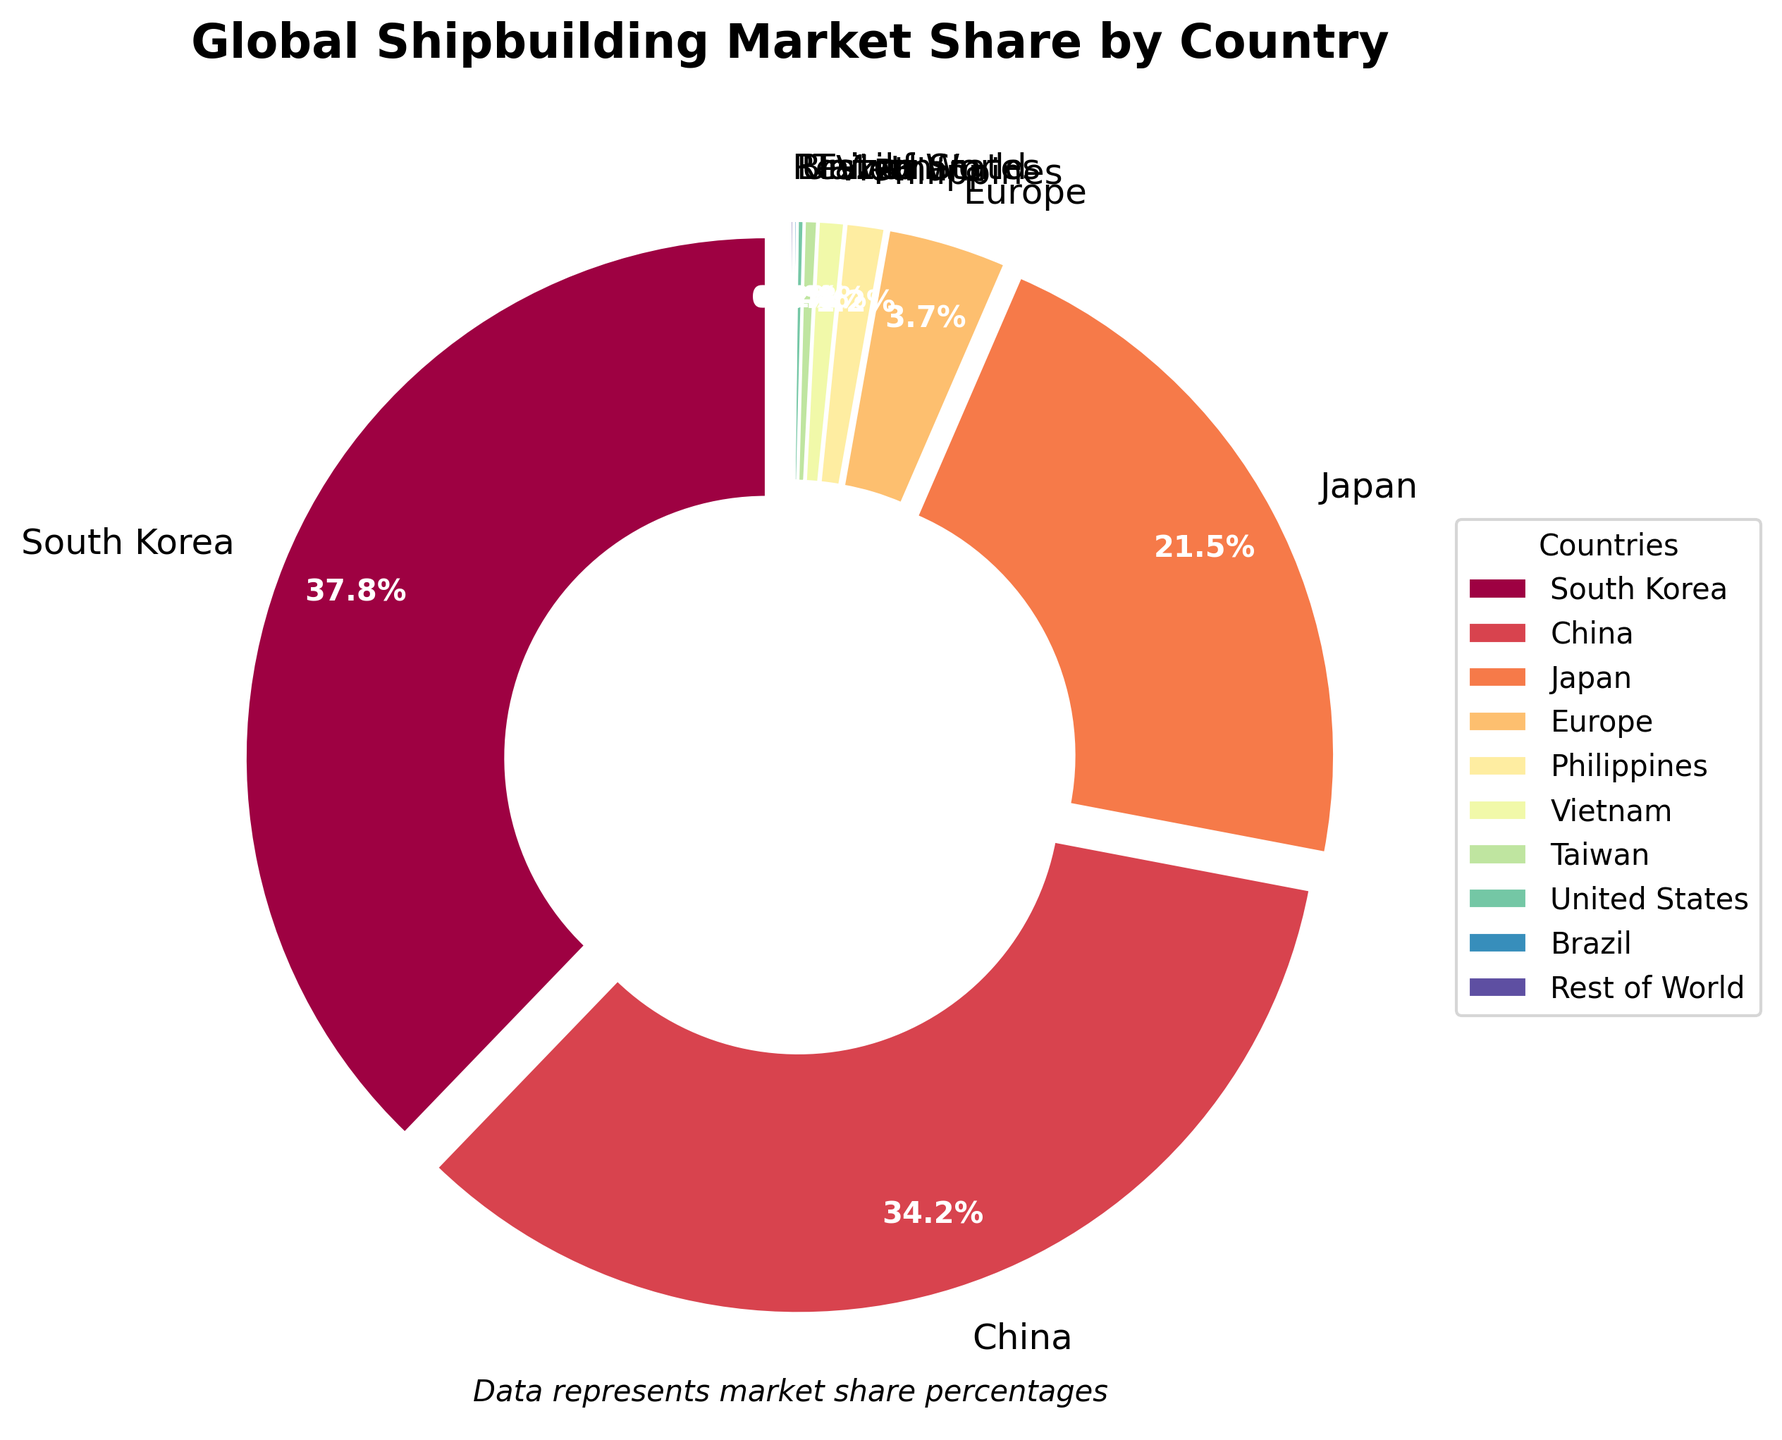What is the combined market share of South Korea and China? To find the combined market share of South Korea and China, add their individual market shares: 37.8% (South Korea) + 34.2% (China) = 72.0%.
Answer: 72.0% Which country has the largest market share? By looking at the figure, South Korea has the largest market share at 37.8%.
Answer: South Korea What is the difference in market share between Japan and Europe? To find the difference in market share between Japan and Europe, subtract Europe's market share from Japan's market share: 21.5% (Japan) - 3.7% (Europe) = 17.8%.
Answer: 17.8% What is the total market share represented by the countries with less than 1% each? Add the market shares of the Philippines (1.2%), Vietnam (0.8%), Taiwan (0.4%), United States (0.2%), and Brazil (0.1%): 0.8% + 0.4% + 0.2% + 0.1% = 1.5%.
Answer: 1.5% Which country has a higher market share, Vietnam or Taiwan? By comparing the market shares, Vietnam has a higher market share of 0.8% compared to Taiwan's 0.4%.
Answer: Vietnam How does the market share of Japan compare to that of South Korea and China combined? The combined market share of South Korea and China is 72.0%. Japan's market share is 21.5%. Therefore, Japan's market share is significantly lower than the combined market share of South Korea and China.
Answer: Significantly lower What is the market share of all countries except South Korea, China, and Japan? Subtract the combined market share of South Korea (37.8%), China (34.2%), and Japan (21.5%) from 100%: 100% - 37.8% - 34.2% - 21.5% = 6.5%.
Answer: 6.5% What percentage of the market share do South Korea, China, and Japan hold together? Add the market shares of South Korea (37.8%), China (34.2%), and Japan (21.5%): 37.8% + 34.2% + 21.5% = 93.5%.
Answer: 93.5% Among the countries listed, which has the smallest market share and how much is it? The figure shows that Brazil and the Rest of the World both have the smallest market share of 0.1% each.
Answer: Brazil and Rest of the World, 0.1% each 